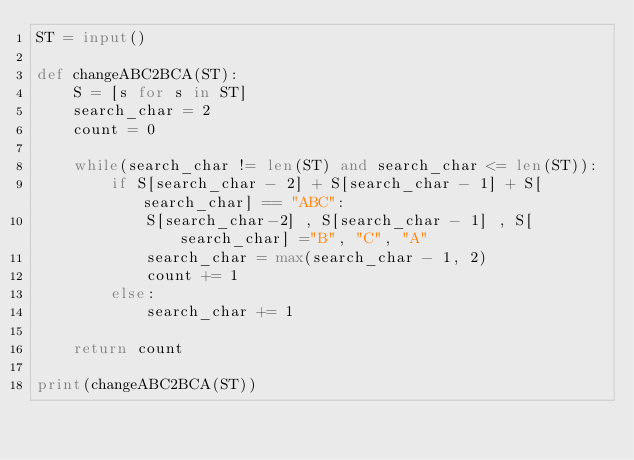<code> <loc_0><loc_0><loc_500><loc_500><_Python_>ST = input()

def changeABC2BCA(ST):
    S = [s for s in ST]
    search_char = 2
    count = 0
    
    while(search_char != len(ST) and search_char <= len(ST)):
        if S[search_char - 2] + S[search_char - 1] + S[search_char] == "ABC":
            S[search_char-2] , S[search_char - 1] , S[search_char] ="B", "C", "A"
            search_char = max(search_char - 1, 2)
            count += 1
        else:
            search_char += 1
    
    return count
  
print(changeABC2BCA(ST))
</code> 